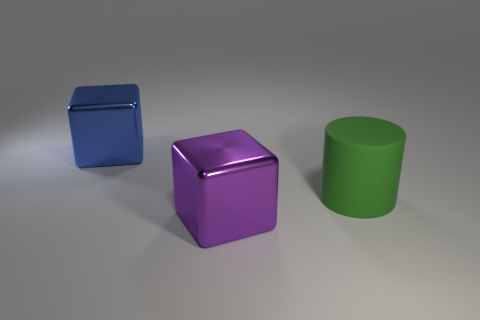What number of things are big shiny objects that are in front of the big blue metal object or yellow metal cylinders?
Provide a succinct answer. 1. Are there any other things that are the same size as the purple metal block?
Your answer should be very brief. Yes. There is a object that is on the right side of the block that is in front of the large cylinder; what is it made of?
Make the answer very short. Rubber. Are there an equal number of large things that are to the right of the large matte cylinder and big rubber cylinders behind the blue cube?
Ensure brevity in your answer.  Yes. How many things are large shiny cubes on the left side of the purple cube or big blocks that are on the left side of the big purple cube?
Offer a very short reply. 1. There is a big thing that is both behind the large purple metal thing and left of the green cylinder; what is its material?
Keep it short and to the point. Metal. How big is the metallic block that is in front of the block behind the big green cylinder that is on the right side of the purple cube?
Your answer should be very brief. Large. Is the number of blue spheres greater than the number of purple objects?
Offer a terse response. No. Is the material of the big cube that is behind the green cylinder the same as the purple cube?
Your answer should be compact. Yes. Is the number of gray rubber cubes less than the number of large cylinders?
Ensure brevity in your answer.  Yes. 